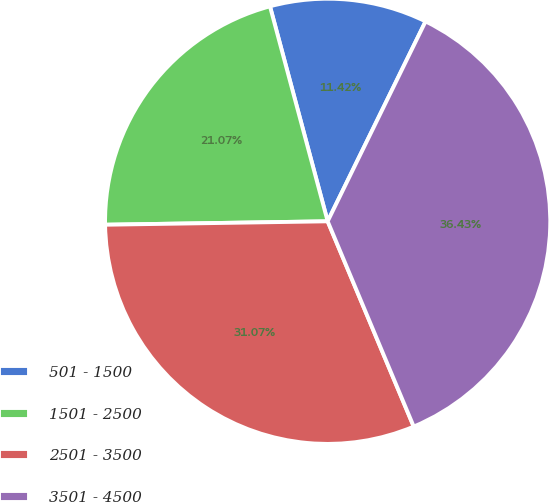Convert chart to OTSL. <chart><loc_0><loc_0><loc_500><loc_500><pie_chart><fcel>501 - 1500<fcel>1501 - 2500<fcel>2501 - 3500<fcel>3501 - 4500<nl><fcel>11.42%<fcel>21.07%<fcel>31.07%<fcel>36.43%<nl></chart> 